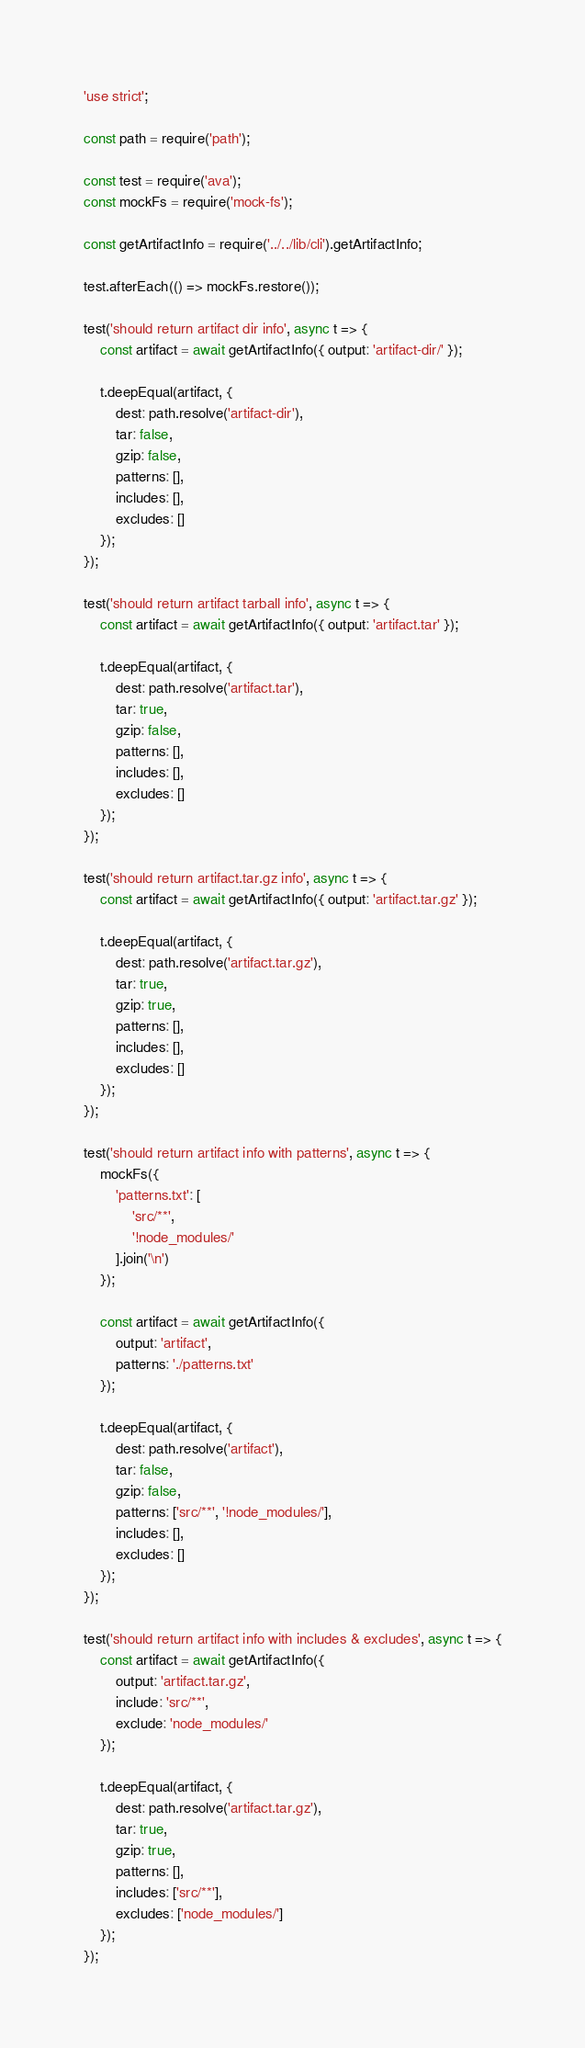<code> <loc_0><loc_0><loc_500><loc_500><_JavaScript_>'use strict';

const path = require('path');

const test = require('ava');
const mockFs = require('mock-fs');

const getArtifactInfo = require('../../lib/cli').getArtifactInfo;

test.afterEach(() => mockFs.restore());

test('should return artifact dir info', async t => {
    const artifact = await getArtifactInfo({ output: 'artifact-dir/' });

    t.deepEqual(artifact, {
        dest: path.resolve('artifact-dir'),
        tar: false,
        gzip: false,
        patterns: [],
        includes: [],
        excludes: []
    });
});

test('should return artifact tarball info', async t => {
    const artifact = await getArtifactInfo({ output: 'artifact.tar' });

    t.deepEqual(artifact, {
        dest: path.resolve('artifact.tar'),
        tar: true,
        gzip: false,
        patterns: [],
        includes: [],
        excludes: []
    });
});

test('should return artifact.tar.gz info', async t => {
    const artifact = await getArtifactInfo({ output: 'artifact.tar.gz' });

    t.deepEqual(artifact, {
        dest: path.resolve('artifact.tar.gz'),
        tar: true,
        gzip: true,
        patterns: [],
        includes: [],
        excludes: []
    });
});

test('should return artifact info with patterns', async t => {
    mockFs({
        'patterns.txt': [
            'src/**',
            '!node_modules/'
        ].join('\n')
    });

    const artifact = await getArtifactInfo({
        output: 'artifact',
        patterns: './patterns.txt'
    });

    t.deepEqual(artifact, {
        dest: path.resolve('artifact'),
        tar: false,
        gzip: false,
        patterns: ['src/**', '!node_modules/'],
        includes: [],
        excludes: []
    });
});

test('should return artifact info with includes & excludes', async t => {
    const artifact = await getArtifactInfo({
        output: 'artifact.tar.gz',
        include: 'src/**',
        exclude: 'node_modules/'
    });

    t.deepEqual(artifact, {
        dest: path.resolve('artifact.tar.gz'),
        tar: true,
        gzip: true,
        patterns: [],
        includes: ['src/**'],
        excludes: ['node_modules/']
    });
});
</code> 